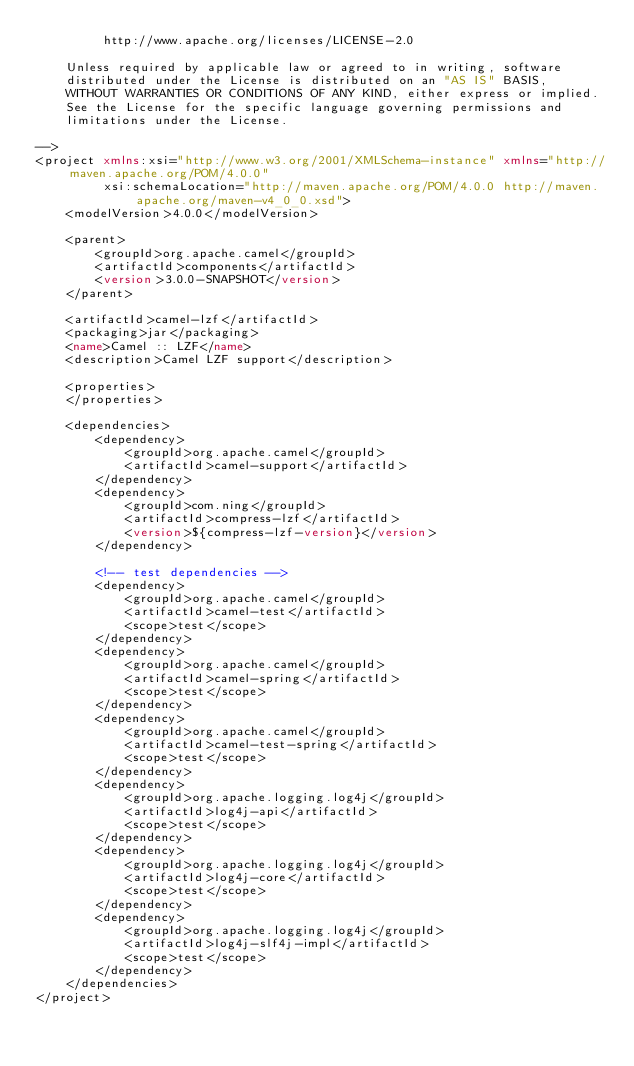<code> <loc_0><loc_0><loc_500><loc_500><_XML_>         http://www.apache.org/licenses/LICENSE-2.0

    Unless required by applicable law or agreed to in writing, software
    distributed under the License is distributed on an "AS IS" BASIS,
    WITHOUT WARRANTIES OR CONDITIONS OF ANY KIND, either express or implied.
    See the License for the specific language governing permissions and
    limitations under the License.

-->
<project xmlns:xsi="http://www.w3.org/2001/XMLSchema-instance" xmlns="http://maven.apache.org/POM/4.0.0"
         xsi:schemaLocation="http://maven.apache.org/POM/4.0.0 http://maven.apache.org/maven-v4_0_0.xsd">
    <modelVersion>4.0.0</modelVersion>

    <parent>
        <groupId>org.apache.camel</groupId>
        <artifactId>components</artifactId>
        <version>3.0.0-SNAPSHOT</version>
    </parent>

    <artifactId>camel-lzf</artifactId>
    <packaging>jar</packaging>
    <name>Camel :: LZF</name>
    <description>Camel LZF support</description>

    <properties>
    </properties>

    <dependencies>
        <dependency>
            <groupId>org.apache.camel</groupId>
            <artifactId>camel-support</artifactId>
        </dependency>
        <dependency>
            <groupId>com.ning</groupId>
            <artifactId>compress-lzf</artifactId>
            <version>${compress-lzf-version}</version>
        </dependency>

        <!-- test dependencies -->
        <dependency>
            <groupId>org.apache.camel</groupId>
            <artifactId>camel-test</artifactId>
            <scope>test</scope>
        </dependency>
        <dependency>
            <groupId>org.apache.camel</groupId>
            <artifactId>camel-spring</artifactId>
            <scope>test</scope>
        </dependency>
        <dependency>
            <groupId>org.apache.camel</groupId>
            <artifactId>camel-test-spring</artifactId>
            <scope>test</scope>
        </dependency>
        <dependency>
            <groupId>org.apache.logging.log4j</groupId>
            <artifactId>log4j-api</artifactId>
            <scope>test</scope>
        </dependency>
        <dependency>
            <groupId>org.apache.logging.log4j</groupId>
            <artifactId>log4j-core</artifactId>
            <scope>test</scope>
        </dependency>
        <dependency>
            <groupId>org.apache.logging.log4j</groupId>
            <artifactId>log4j-slf4j-impl</artifactId>
            <scope>test</scope>
        </dependency>
    </dependencies>
</project>
</code> 